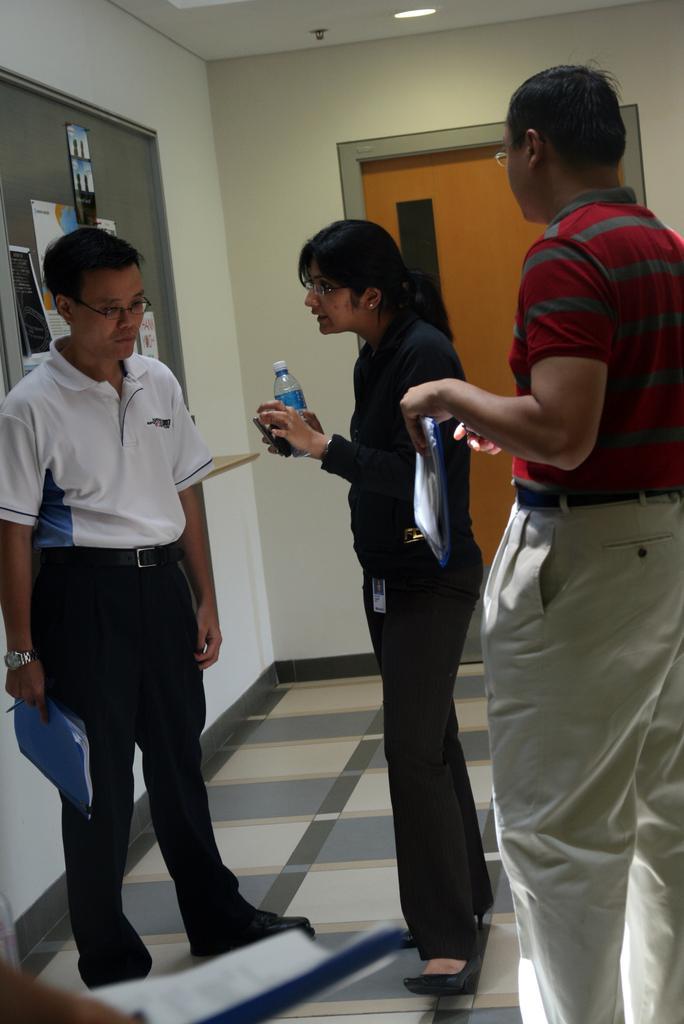Please provide a concise description of this image. There are two men and one woman standing. This looks like a notice board with the posters attached to it. This is the door. I can see the woman holding a water bottle and mobile phone in her hand. I can see a ceiling light attached to the roof. At the bottom of the image, I think here is a person holding a file. 